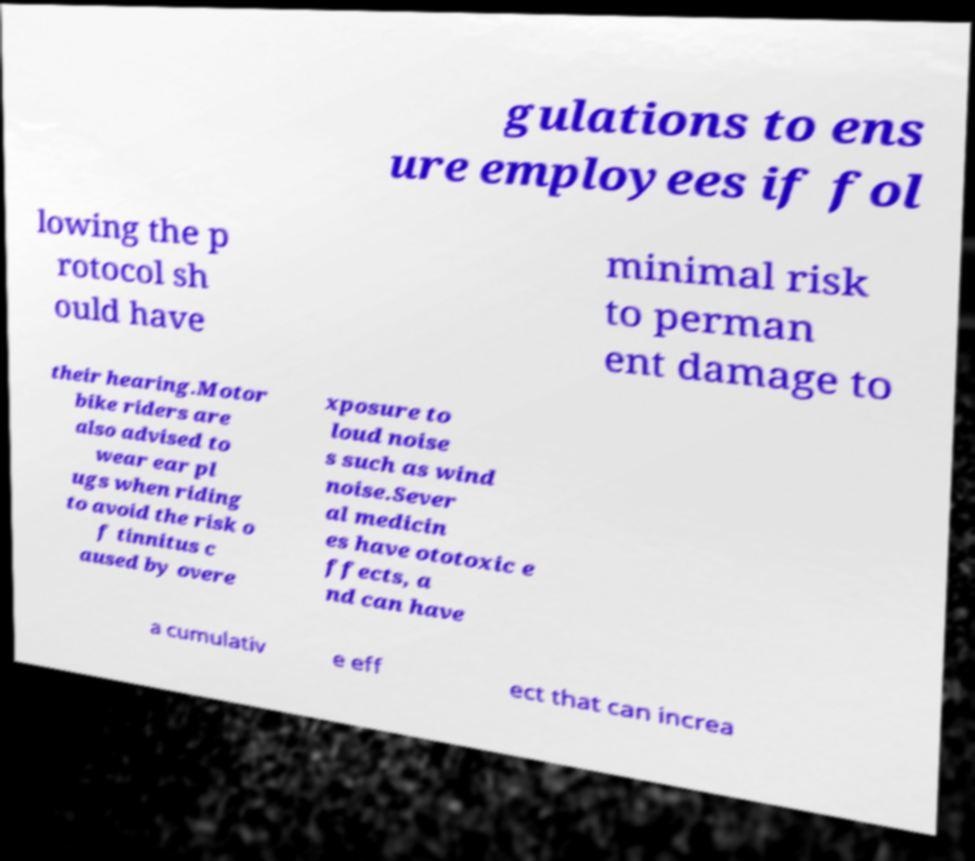Could you assist in decoding the text presented in this image and type it out clearly? gulations to ens ure employees if fol lowing the p rotocol sh ould have minimal risk to perman ent damage to their hearing.Motor bike riders are also advised to wear ear pl ugs when riding to avoid the risk o f tinnitus c aused by overe xposure to loud noise s such as wind noise.Sever al medicin es have ototoxic e ffects, a nd can have a cumulativ e eff ect that can increa 